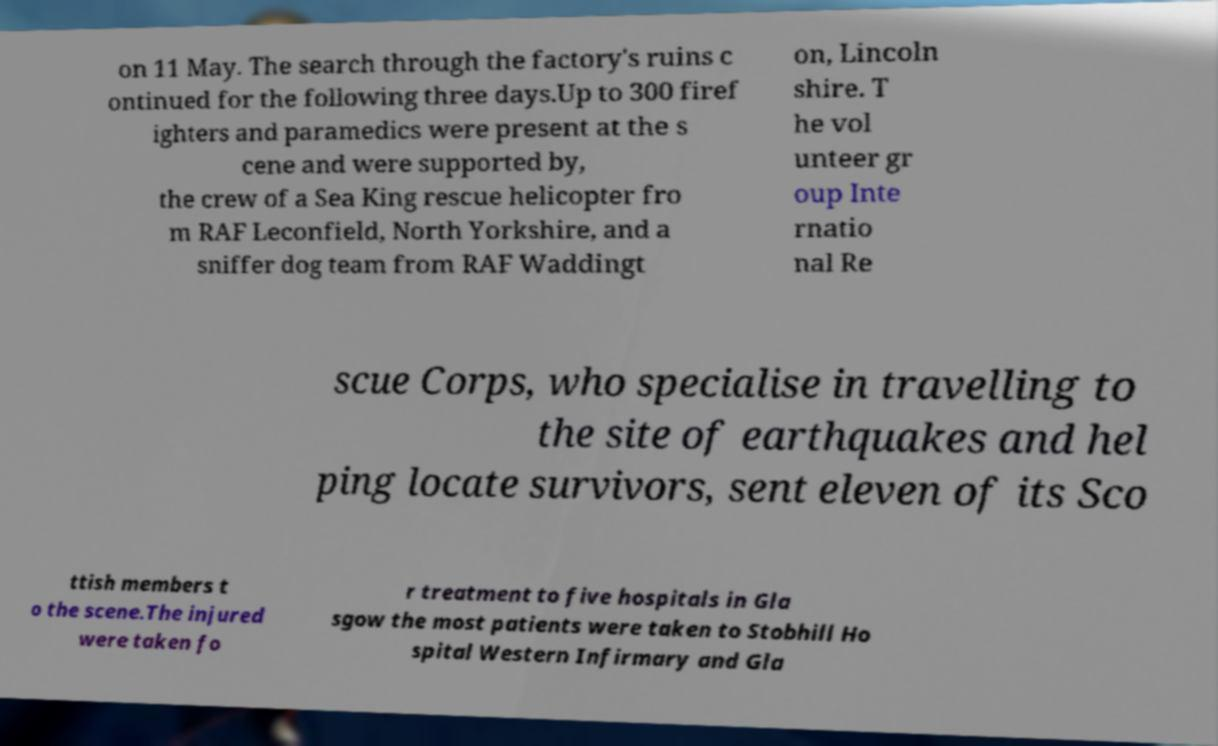Please identify and transcribe the text found in this image. on 11 May. The search through the factory's ruins c ontinued for the following three days.Up to 300 firef ighters and paramedics were present at the s cene and were supported by, the crew of a Sea King rescue helicopter fro m RAF Leconfield, North Yorkshire, and a sniffer dog team from RAF Waddingt on, Lincoln shire. T he vol unteer gr oup Inte rnatio nal Re scue Corps, who specialise in travelling to the site of earthquakes and hel ping locate survivors, sent eleven of its Sco ttish members t o the scene.The injured were taken fo r treatment to five hospitals in Gla sgow the most patients were taken to Stobhill Ho spital Western Infirmary and Gla 